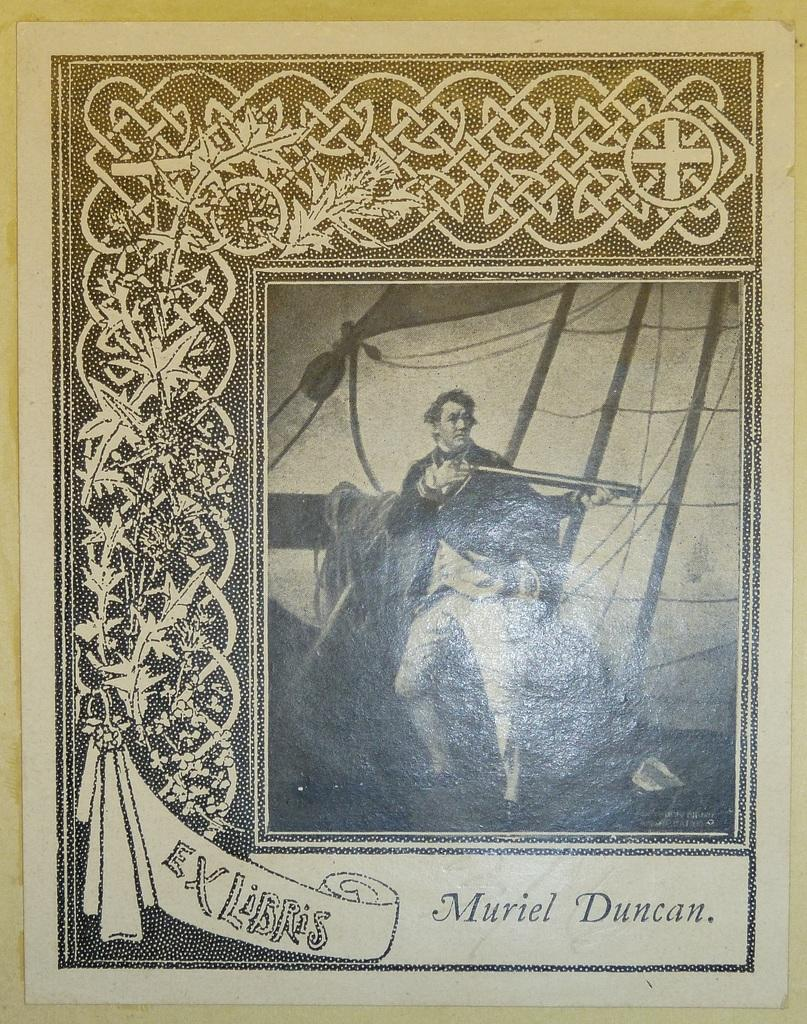What type of artwork is depicted in the image? The image is a painting. Can you describe the subject matter of the painting? There is a person in the painting. Where is the throne located in the painting? There is no throne present in the painting; it only features a person. What type of sea creatures can be seen in the painting? There are no sea creatures present in the painting; it only features a person. 